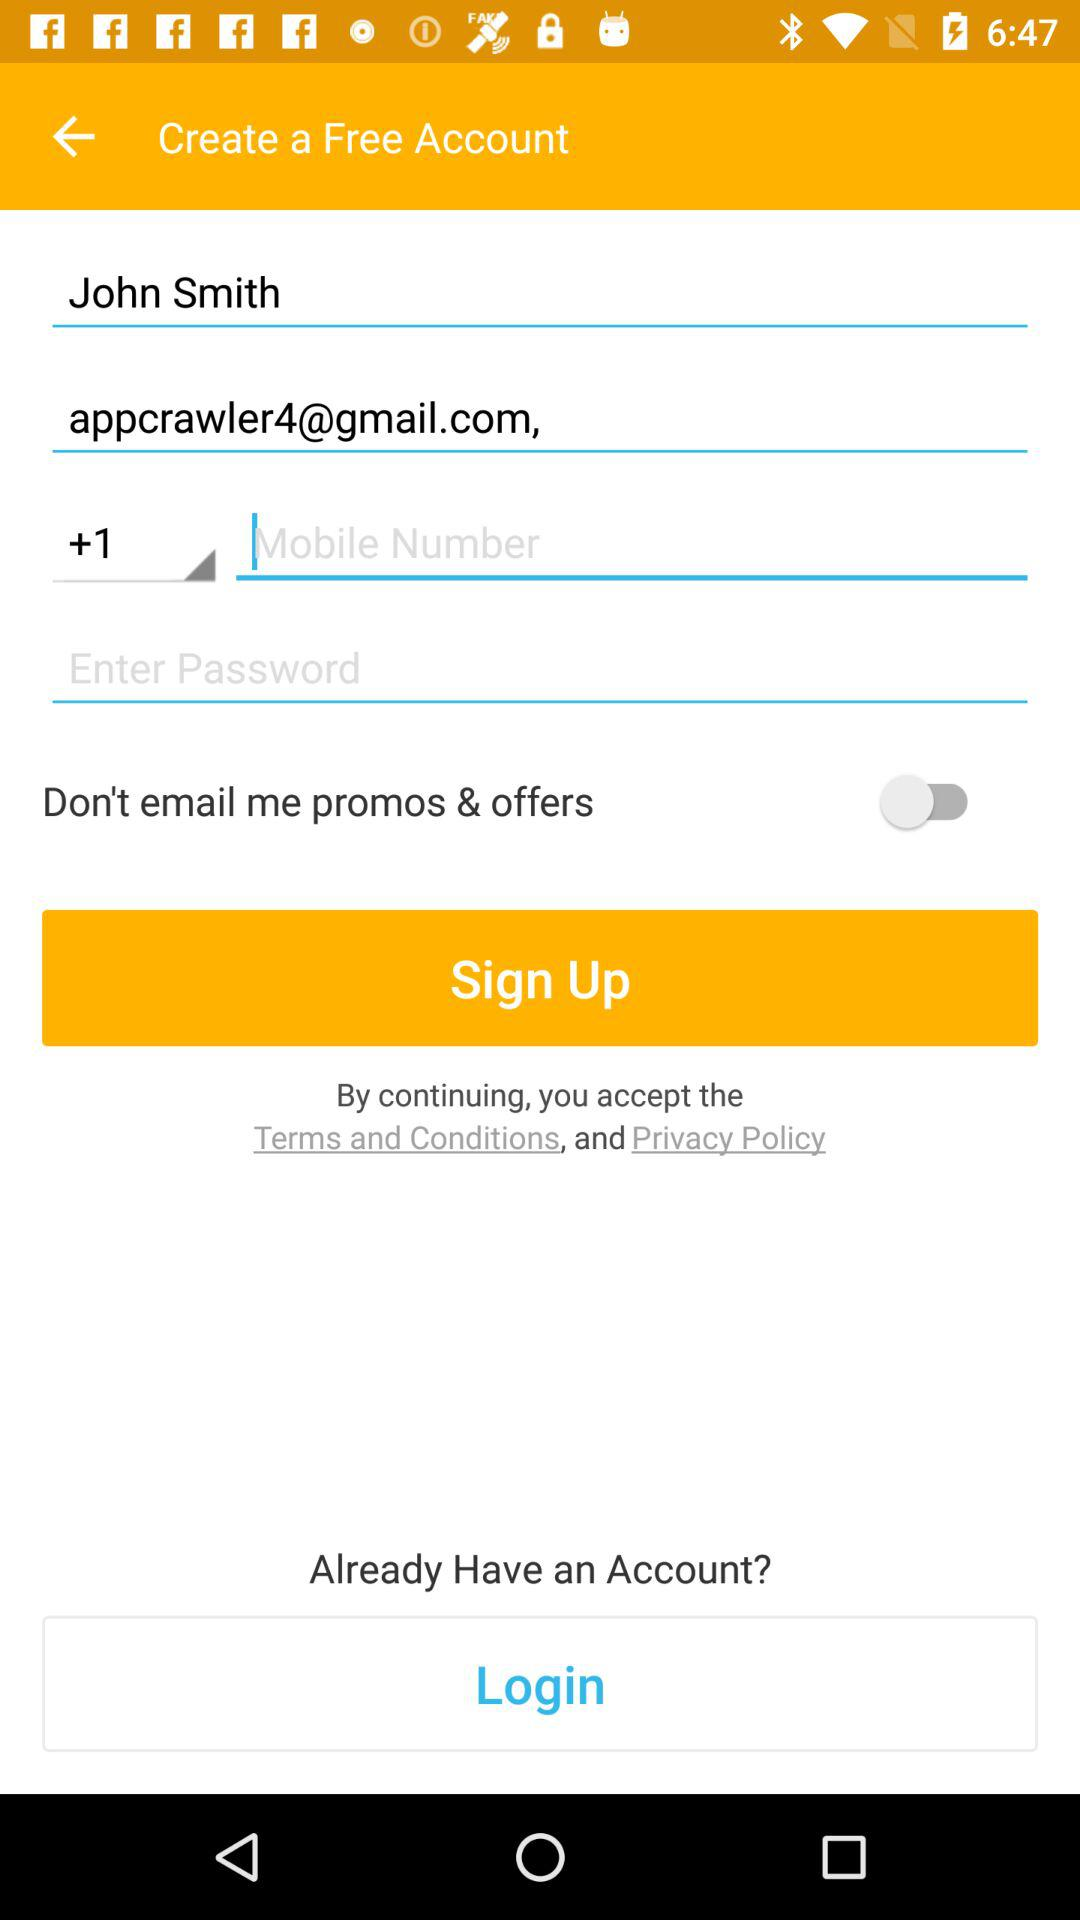What is the user name? The user name is John Smith. 